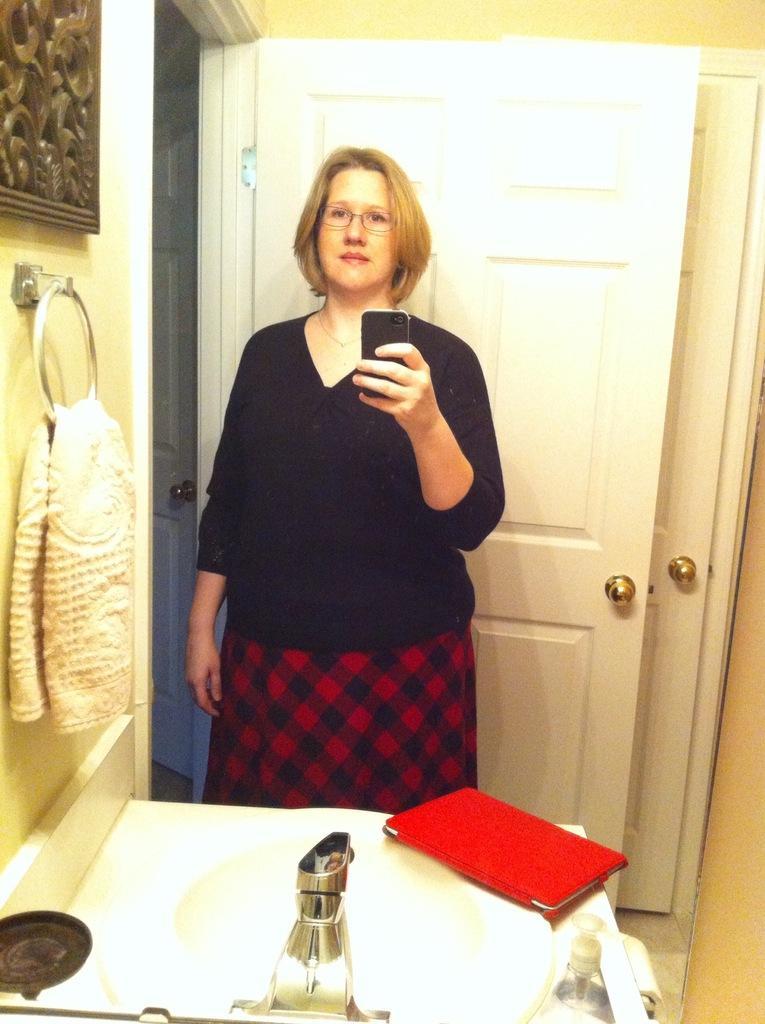Describe this image in one or two sentences. In this picture we can see a woman, she is holding a mobile, in front of her we can see a sink, cloth and some objects and in the background we can see a wall, door. 